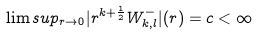Convert formula to latex. <formula><loc_0><loc_0><loc_500><loc_500>\lim s u p _ { r \rightarrow 0 } | r ^ { k + \frac { 1 } { 2 } } W _ { k , l } ^ { - } | ( r ) = c < \infty</formula> 